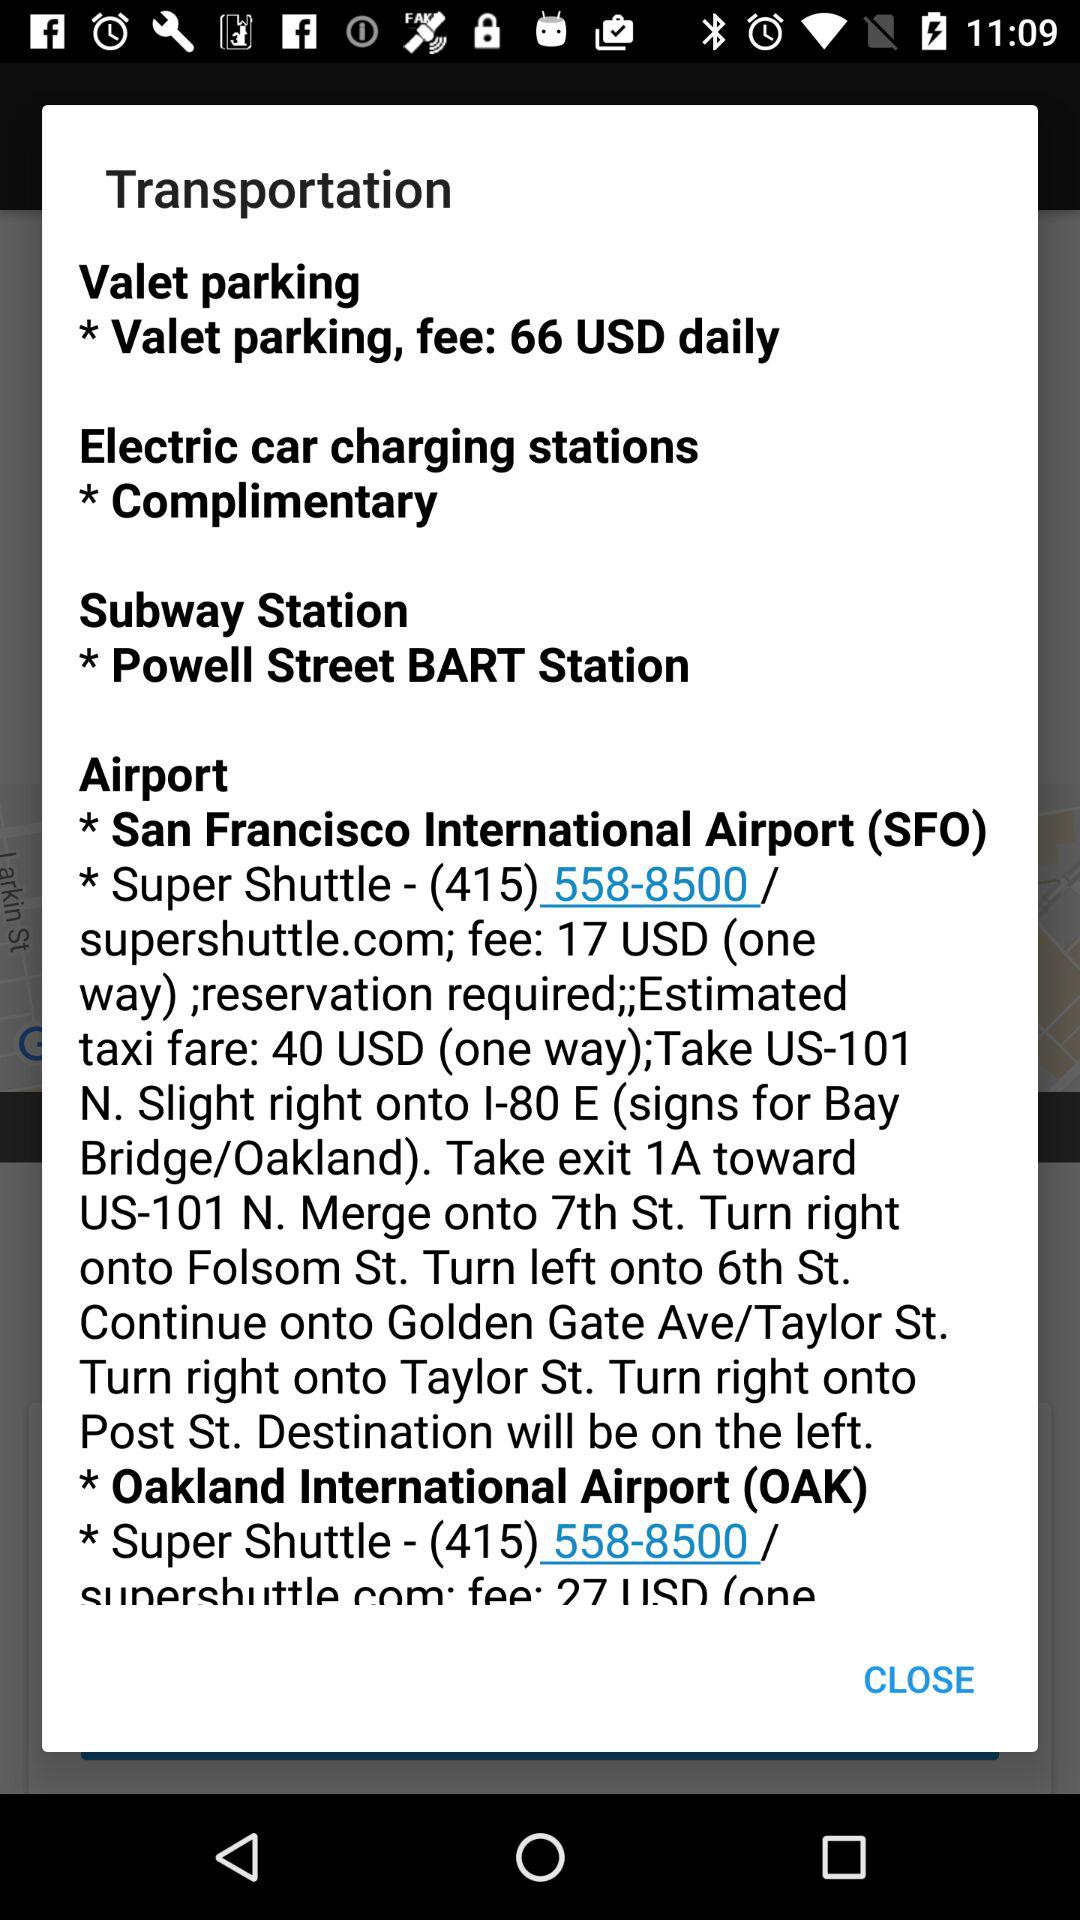What is the contact number for the super shuttle? The contact number is "(415) 558-8500". 